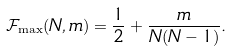Convert formula to latex. <formula><loc_0><loc_0><loc_500><loc_500>\mathcal { F } _ { \max } ( N , m ) = \frac { 1 } { 2 } + \frac { m } { N ( N - 1 ) } .</formula> 